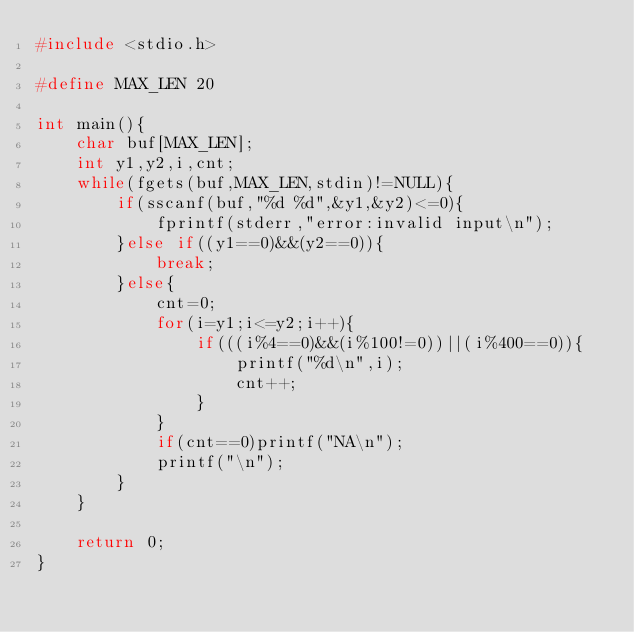<code> <loc_0><loc_0><loc_500><loc_500><_C_>#include <stdio.h>

#define MAX_LEN 20

int main(){
	char buf[MAX_LEN];
	int y1,y2,i,cnt;
	while(fgets(buf,MAX_LEN,stdin)!=NULL){
		if(sscanf(buf,"%d %d",&y1,&y2)<=0){
			fprintf(stderr,"error:invalid input\n");
		}else if((y1==0)&&(y2==0)){
			break;
		}else{
			cnt=0;
			for(i=y1;i<=y2;i++){
				if(((i%4==0)&&(i%100!=0))||(i%400==0)){
					printf("%d\n",i);
					cnt++;
				}
			}
			if(cnt==0)printf("NA\n");
			printf("\n");
		}
	}
	
	return 0;
}</code> 